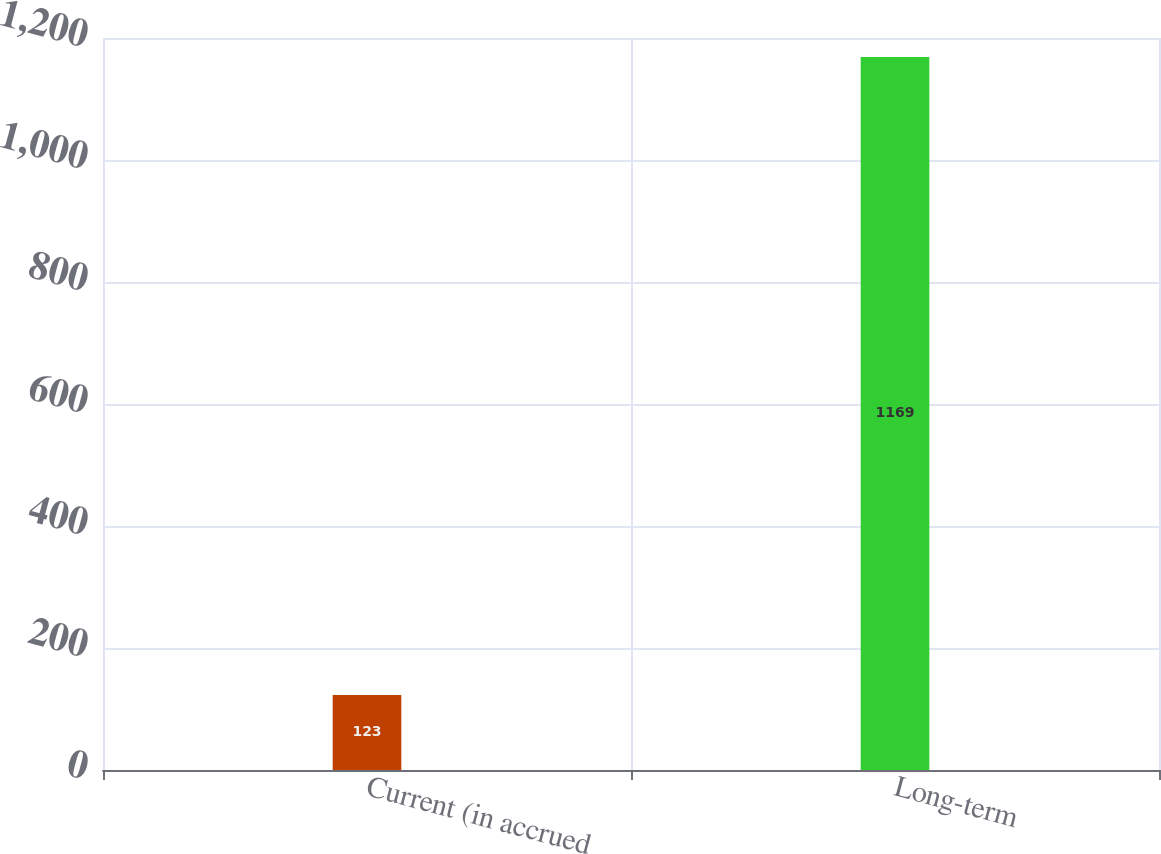Convert chart. <chart><loc_0><loc_0><loc_500><loc_500><bar_chart><fcel>Current (in accrued<fcel>Long-term<nl><fcel>123<fcel>1169<nl></chart> 